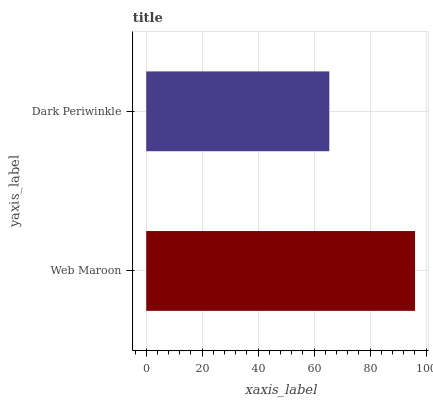Is Dark Periwinkle the minimum?
Answer yes or no. Yes. Is Web Maroon the maximum?
Answer yes or no. Yes. Is Dark Periwinkle the maximum?
Answer yes or no. No. Is Web Maroon greater than Dark Periwinkle?
Answer yes or no. Yes. Is Dark Periwinkle less than Web Maroon?
Answer yes or no. Yes. Is Dark Periwinkle greater than Web Maroon?
Answer yes or no. No. Is Web Maroon less than Dark Periwinkle?
Answer yes or no. No. Is Web Maroon the high median?
Answer yes or no. Yes. Is Dark Periwinkle the low median?
Answer yes or no. Yes. Is Dark Periwinkle the high median?
Answer yes or no. No. Is Web Maroon the low median?
Answer yes or no. No. 